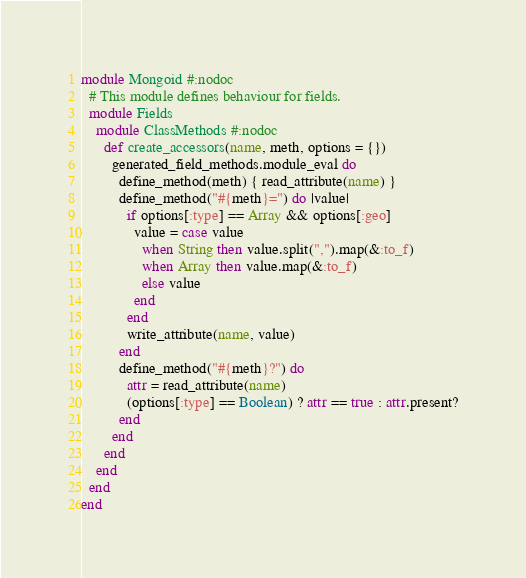<code> <loc_0><loc_0><loc_500><loc_500><_Ruby_>module Mongoid #:nodoc
  # This module defines behaviour for fields.
  module Fields
    module ClassMethods #:nodoc
      def create_accessors(name, meth, options = {})
        generated_field_methods.module_eval do
          define_method(meth) { read_attribute(name) }
          define_method("#{meth}=") do |value| 
            if options[:type] == Array && options[:geo]
              value = case value
                when String then value.split(",").map(&:to_f)
                when Array then value.map(&:to_f)
                else value
              end
            end
            write_attribute(name, value) 
          end
          define_method("#{meth}?") do
            attr = read_attribute(name)
            (options[:type] == Boolean) ? attr == true : attr.present?
          end
        end
      end
    end
  end
end</code> 